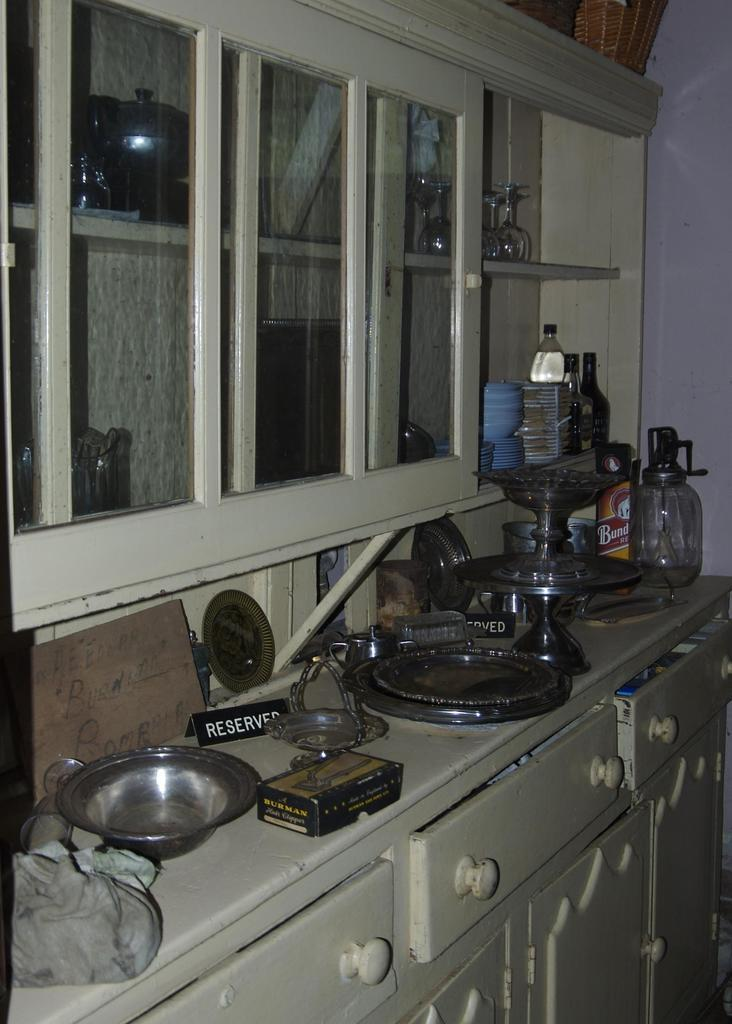Provide a one-sentence caption for the provided image. A lot of bowls and plates are sitting out on a counter next to a Reserved sign. 